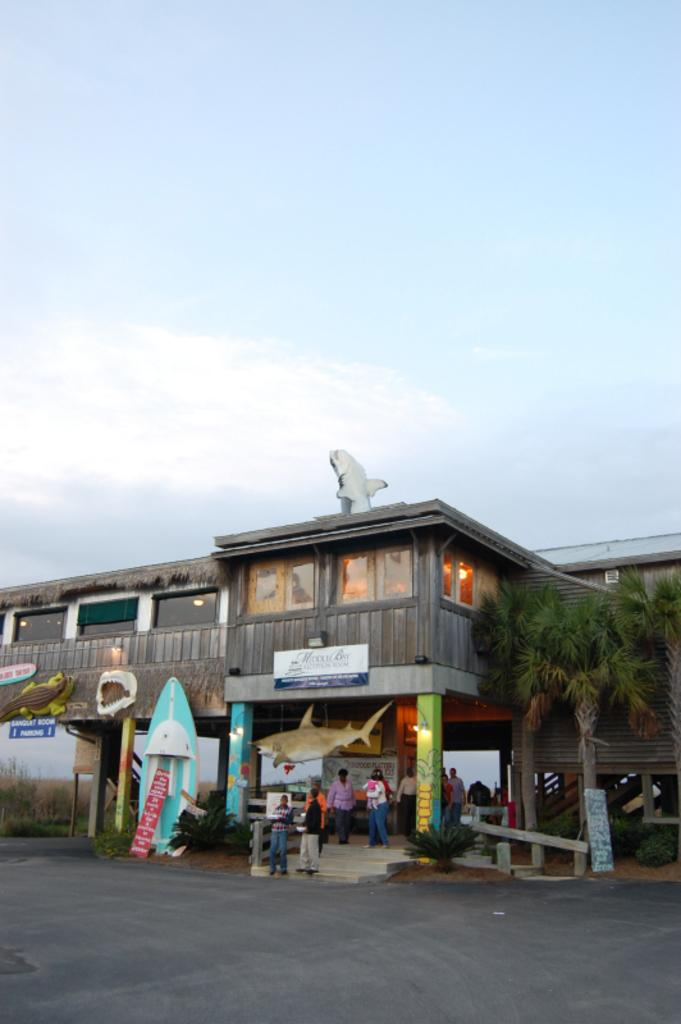What type of structure can be seen in the image? There is a building in the image. What else is present in the image besides the building? There is a road, plants, trees, boards, pillars, statues of animals, people, lights, and the sky is visible in the background with clouds. Can you describe the road in the image? The road is visible in the image. What type of vegetation can be seen in the image? Plants and trees are present in the image. What architectural features can be seen in the image? Boards and pillars are visible in the image. What type of artwork is present in the image? Statues of animals are present in the image. Are there any people in the image? Yes, there are people in the image. What type of lighting is present in the image? Lights are visible in the image. What can be seen in the sky in the image? The sky is visible in the background of the image with clouds. What is the acoustics like in the image? The image does not provide information about the acoustics of the scene. What is the chance of winning a prize in the image? There is no indication of a prize or a game in the image. 